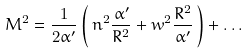Convert formula to latex. <formula><loc_0><loc_0><loc_500><loc_500>M ^ { 2 } = \frac { 1 } { 2 \alpha ^ { \prime } } \left ( \, n ^ { 2 } \frac { \alpha ^ { \prime } } { R ^ { 2 } } + w ^ { 2 } \frac { R ^ { 2 } } { \alpha ^ { \prime } } \, \right ) + \dots</formula> 